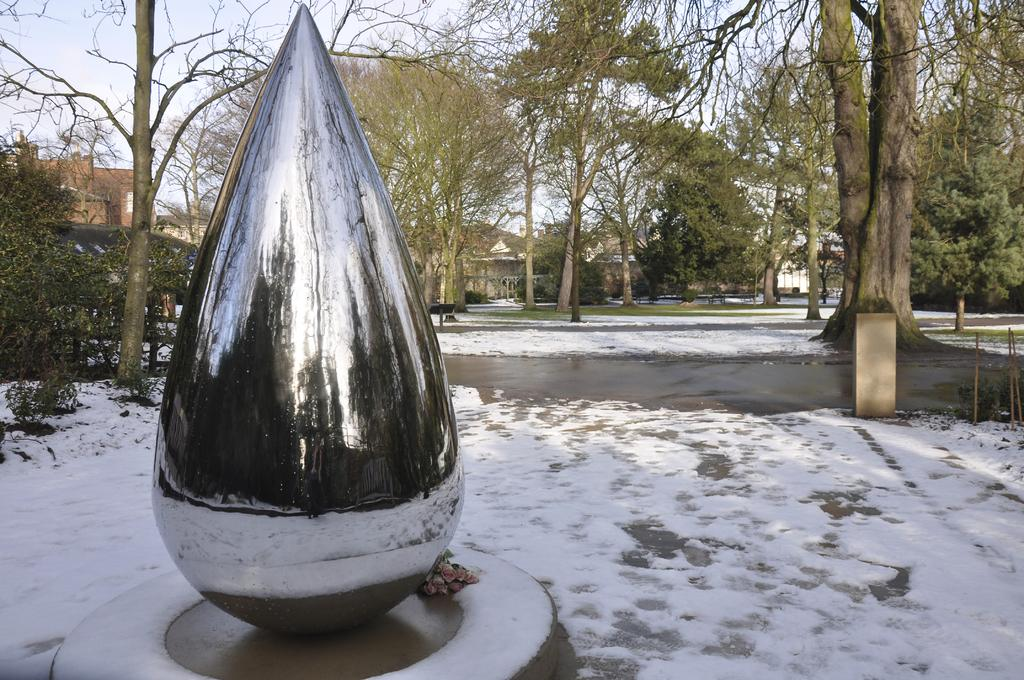What is the main subject of the image? There is a sculpture in the image. What else can be seen in the image besides the sculpture? There are buildings, trees, poles, grass, snow, and the sky visible in the image. Can you describe the environment in the image? The image features a mix of natural elements, such as trees and grass, and man-made structures, like buildings and poles. There is also snow on the ground. What is visible in the sky? The sky is visible in the image. What type of honey can be seen dripping from the pencil in the image? There is no pencil or honey present in the image. 